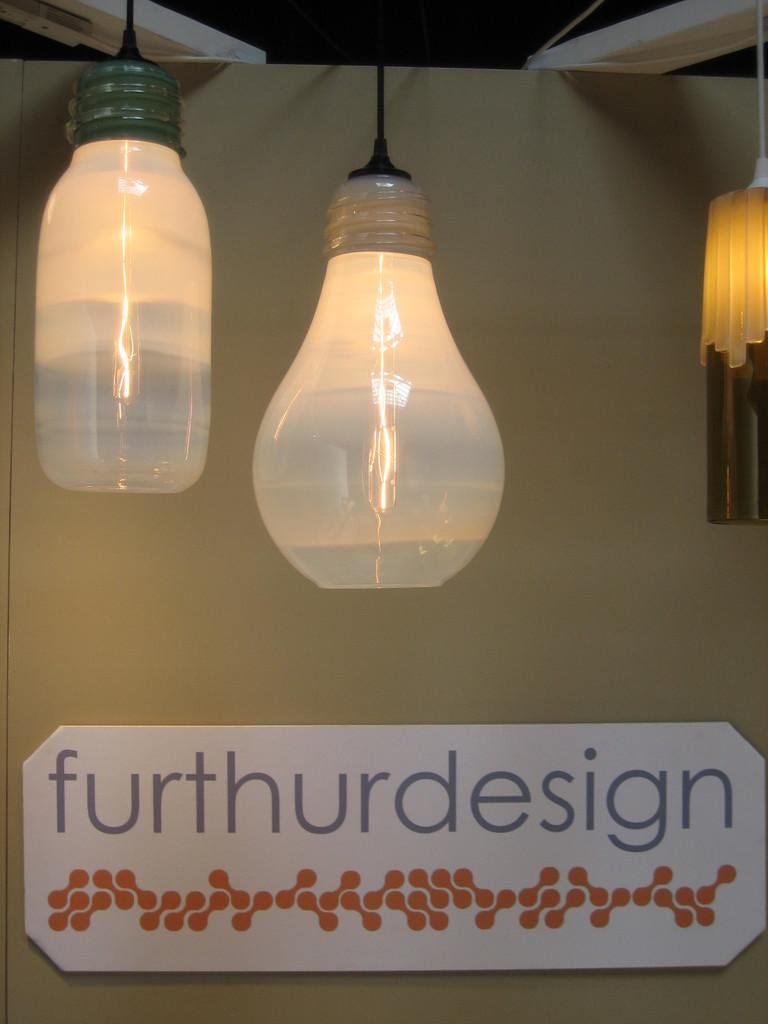Provide a one-sentence caption for the provided image. A decor setting that shows mason jar style lights hanging from above a sign that reads Furthurdesign. 